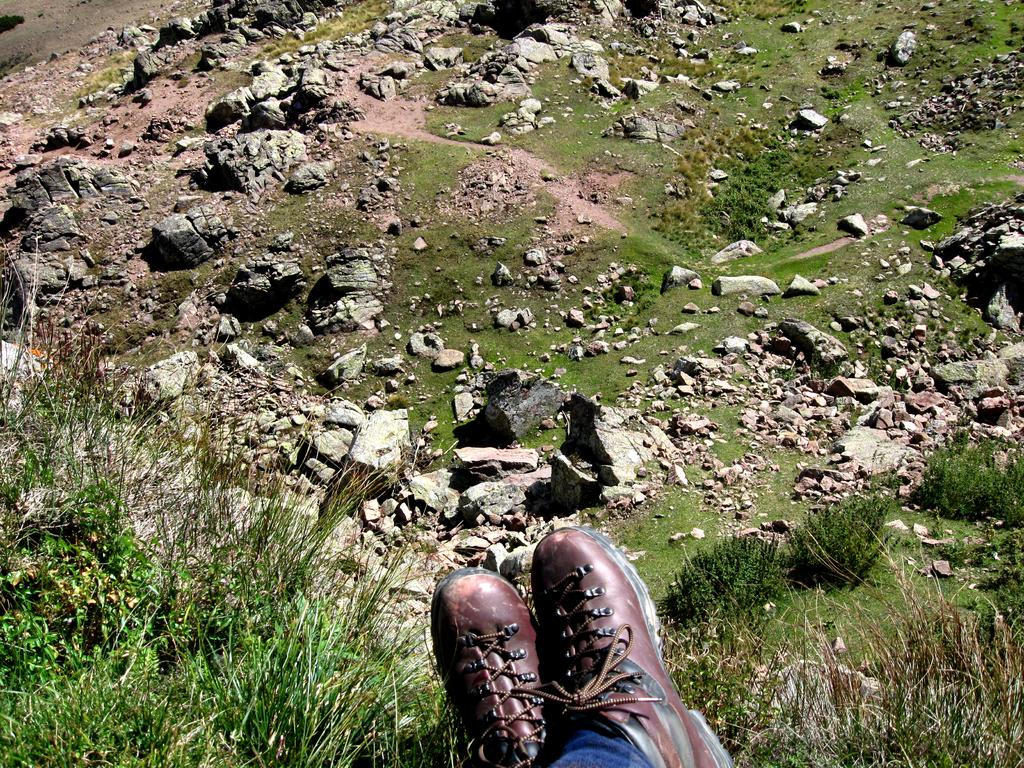What is at the bottom of the image? There are shares of a person at the bottom of the image. What type of living organisms can be seen in the image? Plants are visible in the image. What type of natural elements can be seen on the ground in the image? Rocks are present on the ground in the image. What type of bread can be seen in the image? There is no bread present in the image. What type of clouds can be seen in the image? There is no reference to clouds in the image, as it features shares of a person, plants, and rocks. 